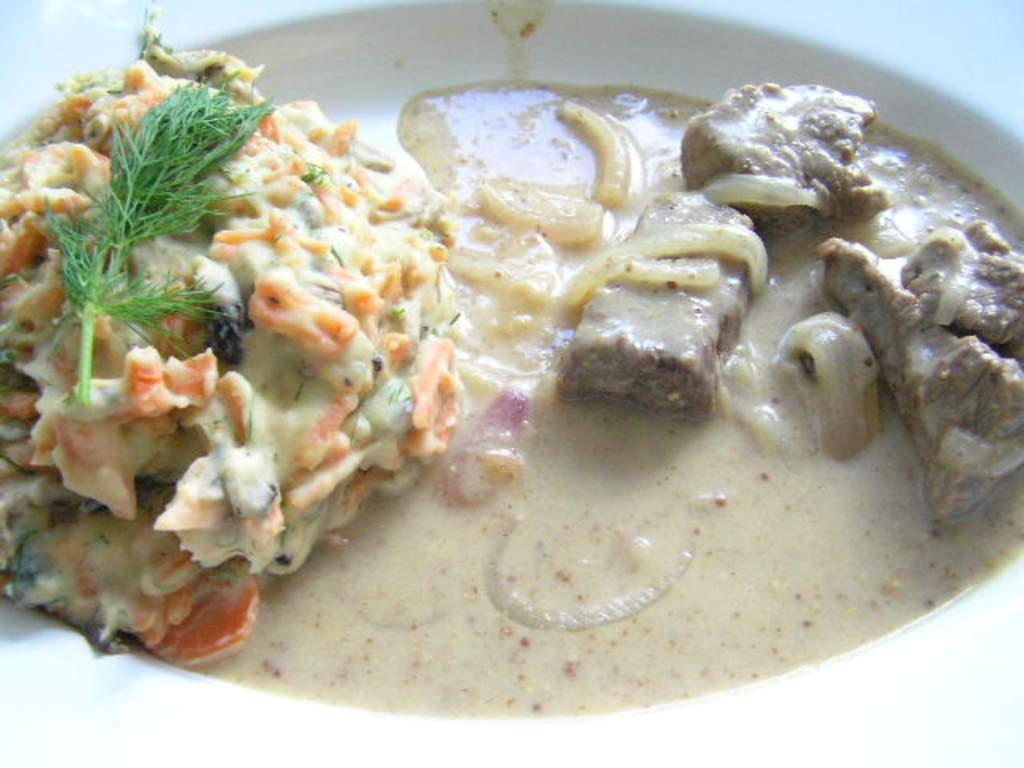Could you give a brief overview of what you see in this image? In this image, we can see a plate contains some food. 